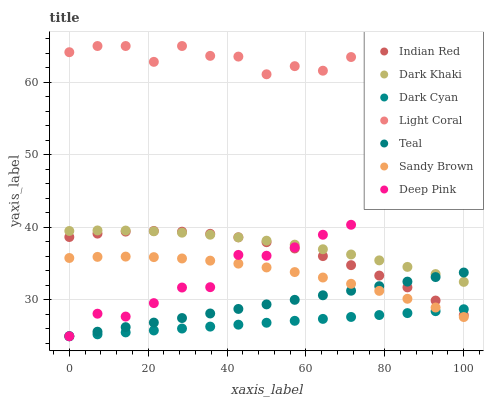Does Dark Cyan have the minimum area under the curve?
Answer yes or no. Yes. Does Light Coral have the maximum area under the curve?
Answer yes or no. Yes. Does Deep Pink have the minimum area under the curve?
Answer yes or no. No. Does Deep Pink have the maximum area under the curve?
Answer yes or no. No. Is Dark Cyan the smoothest?
Answer yes or no. Yes. Is Light Coral the roughest?
Answer yes or no. Yes. Is Deep Pink the smoothest?
Answer yes or no. No. Is Deep Pink the roughest?
Answer yes or no. No. Does Deep Pink have the lowest value?
Answer yes or no. Yes. Does Indian Red have the lowest value?
Answer yes or no. No. Does Light Coral have the highest value?
Answer yes or no. Yes. Does Deep Pink have the highest value?
Answer yes or no. No. Is Sandy Brown less than Light Coral?
Answer yes or no. Yes. Is Indian Red greater than Sandy Brown?
Answer yes or no. Yes. Does Dark Cyan intersect Indian Red?
Answer yes or no. Yes. Is Dark Cyan less than Indian Red?
Answer yes or no. No. Is Dark Cyan greater than Indian Red?
Answer yes or no. No. Does Sandy Brown intersect Light Coral?
Answer yes or no. No. 